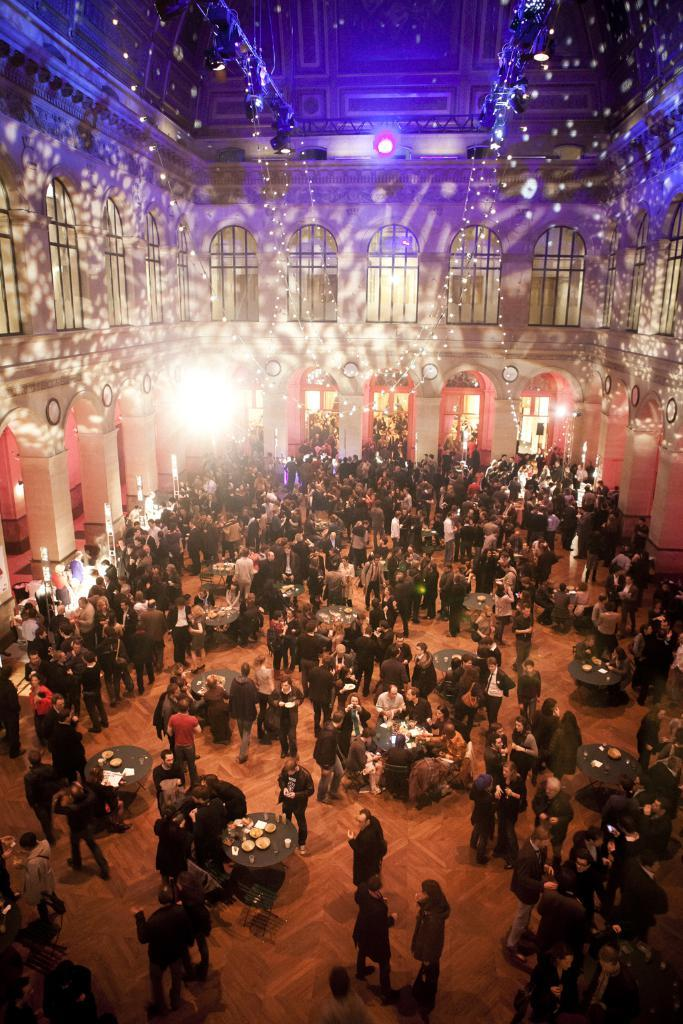What is the main focus of the image? There are people in the center of the image. What objects are present in the image besides the people? There are tables in the image. What can be seen in the background of the image? There is a building with windows in the background of the image. What architectural features are present on the building? The building has pillars. What is visible at the top of the image? There are lights visible at the top of the image. What type of lace is being used to decorate the tables in the image? There is no lace visible on the tables in the image. What time of day is the image depicting, given the presence of lights at the top? The presence of lights at the top does not necessarily indicate the time of day; it could be daytime or nighttime. 